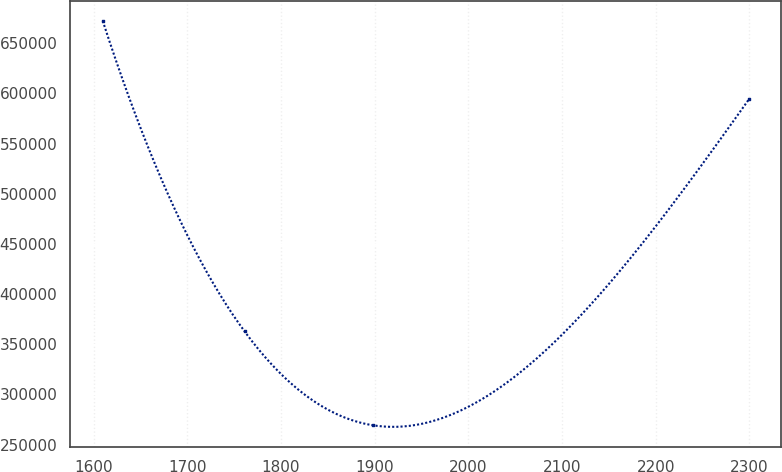Convert chart to OTSL. <chart><loc_0><loc_0><loc_500><loc_500><line_chart><ecel><fcel>Unnamed: 1<nl><fcel>1609.91<fcel>672298<nl><fcel>1761.25<fcel>362781<nl><fcel>1898.3<fcel>269165<nl><fcel>2299.41<fcel>594065<nl></chart> 